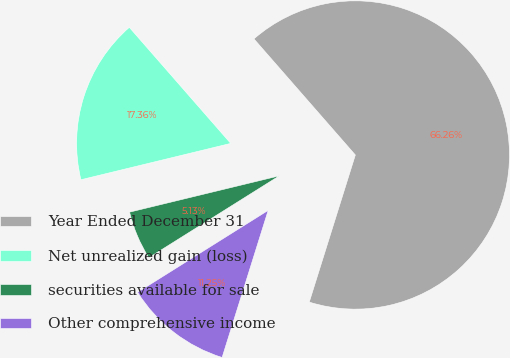Convert chart to OTSL. <chart><loc_0><loc_0><loc_500><loc_500><pie_chart><fcel>Year Ended December 31<fcel>Net unrealized gain (loss)<fcel>securities available for sale<fcel>Other comprehensive income<nl><fcel>66.26%<fcel>17.36%<fcel>5.13%<fcel>11.25%<nl></chart> 